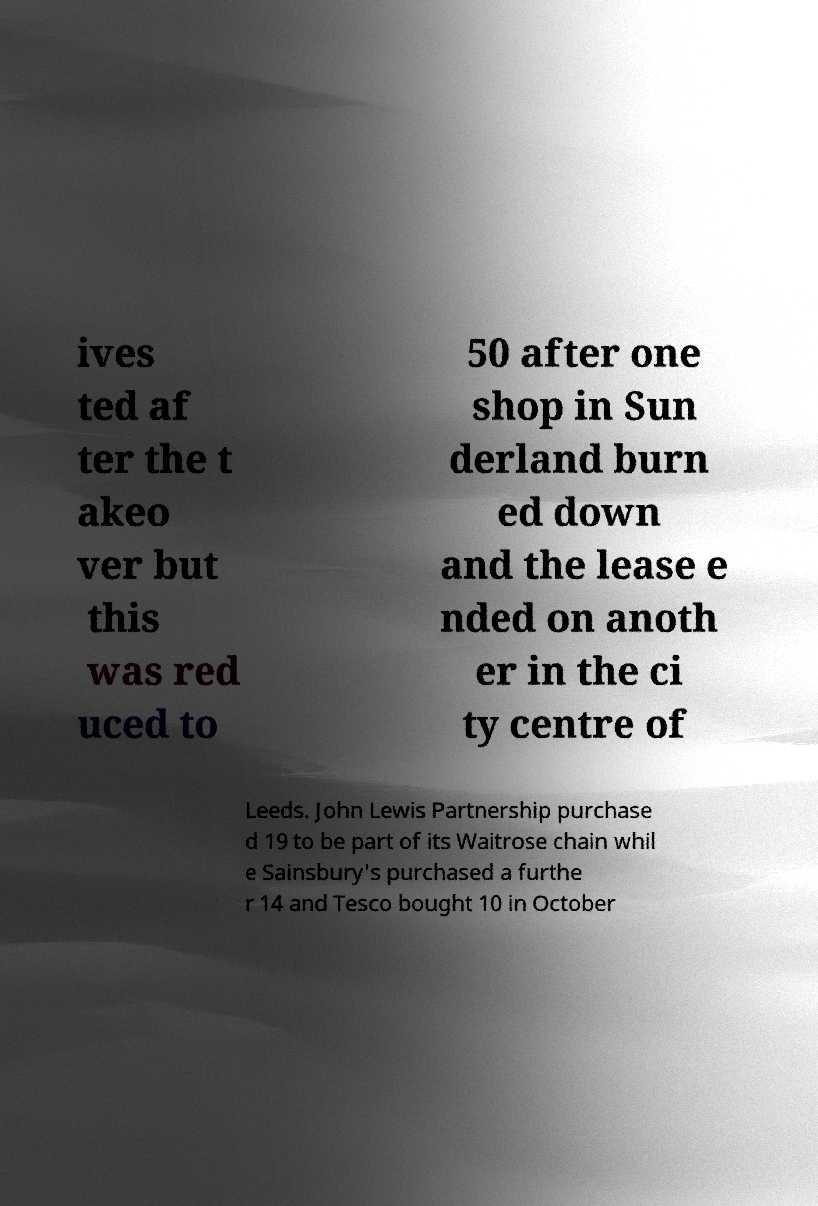What messages or text are displayed in this image? I need them in a readable, typed format. ives ted af ter the t akeo ver but this was red uced to 50 after one shop in Sun derland burn ed down and the lease e nded on anoth er in the ci ty centre of Leeds. John Lewis Partnership purchase d 19 to be part of its Waitrose chain whil e Sainsbury's purchased a furthe r 14 and Tesco bought 10 in October 